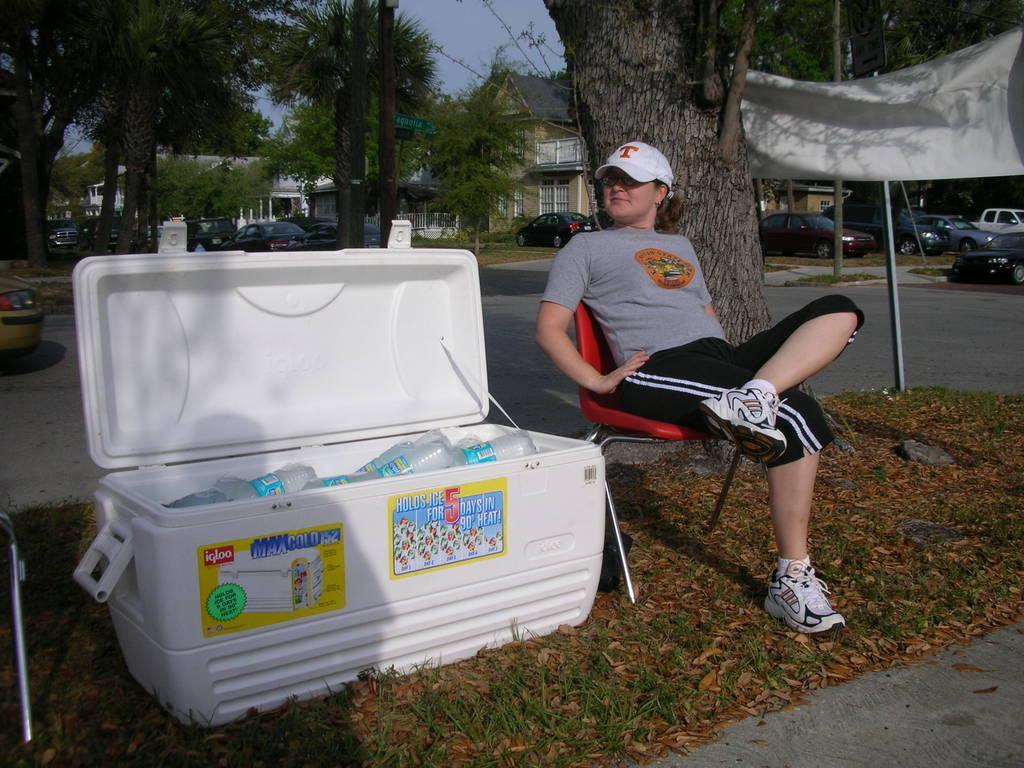How would you summarize this image in a sentence or two? On the right side of the image we can see a woman, she is seated on the chair and she wore a cap, beside to her we can see a box with bottles in it, in the background we can see few trees, vehicles and buildings, and also we can see a pole. 